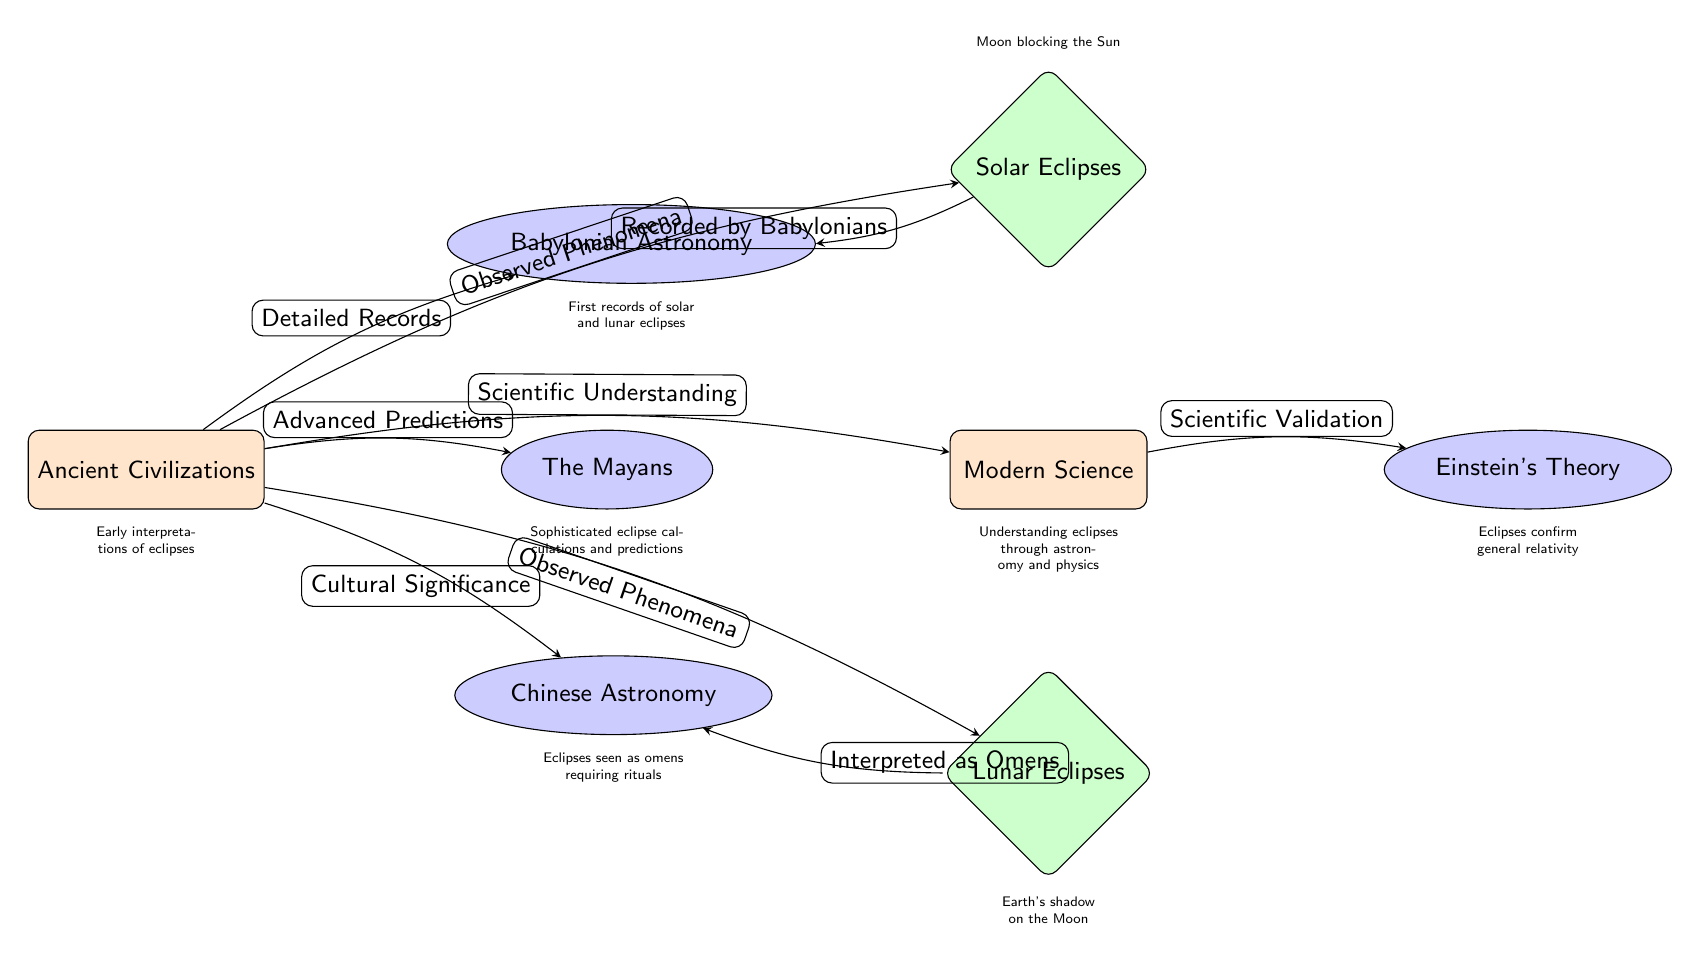What are the main categories shown in the diagram? The diagram displays the main categories as Ancient Civilizations, Modern Science, Solar Eclipses, Lunar Eclipses, Babylonian Astronomy, The Mayans, Chinese Astronomy, and Einstein's Theory.
Answer: Ancient Civilizations, Modern Science, Solar Eclipses, Lunar Eclipses How many secondary nodes are there in the diagram? The secondary nodes are Babylonian Astronomy, The Mayans, Chinese Astronomy, and Einstein's Theory. Counting these gives us a total of four secondary nodes.
Answer: 4 What is indicated as the relationship between Ancient Civilizations and Modern Science? The arrow shows that there is a relationship in which Ancient Civilizations provided a basis for Scientific Understanding, leading to Modern Science.
Answer: Scientific Understanding Which civilization is associated with detailed records of celestial events? The arrow from Ancient Civilizations to Babylonian Astronomy indicates this civilization had detailed records of solar and lunar eclipses.
Answer: Babylonian Astronomy What phenomenon is described as being recorded by Babylonians? The arrow connecting Solar Eclipses to Babylonian Astronomy states that solar eclipses were recorded by Babylonians.
Answer: Solar Eclipses What cultural perspective was given to lunar eclipses in Chinese Astronomy? The relationship between Lunar Eclipses and Chinese Astronomy indicates lunar eclipses were interpreted as omens requiring rituals.
Answer: Interpreted as Omens What concept links eclipses to Einstein’s Theory? The edge indicates that eclipses serve as evidence to confirm general relativity, which directly connects those astronomical events to Einstein's work.
Answer: Scientific Validation What is the significance of the edge between Modern Science and its relationship with eclipses? The edge signifies that Modern Science built upon knowledge from ancient civilizations, thus leading to advancements in understanding eclipses through astronomy and physics.
Answer: Understanding eclipses through astronomy and physics 